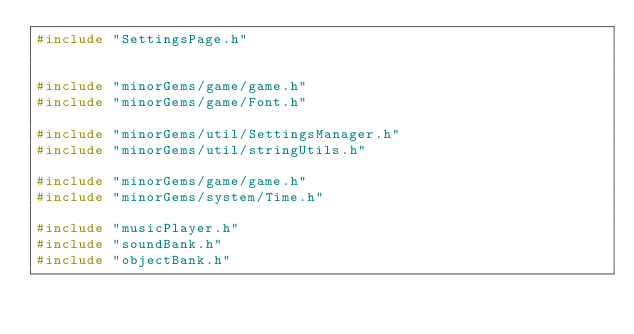<code> <loc_0><loc_0><loc_500><loc_500><_C++_>#include "SettingsPage.h"


#include "minorGems/game/game.h"
#include "minorGems/game/Font.h"

#include "minorGems/util/SettingsManager.h"
#include "minorGems/util/stringUtils.h"

#include "minorGems/game/game.h"
#include "minorGems/system/Time.h"

#include "musicPlayer.h"
#include "soundBank.h"
#include "objectBank.h"</code> 